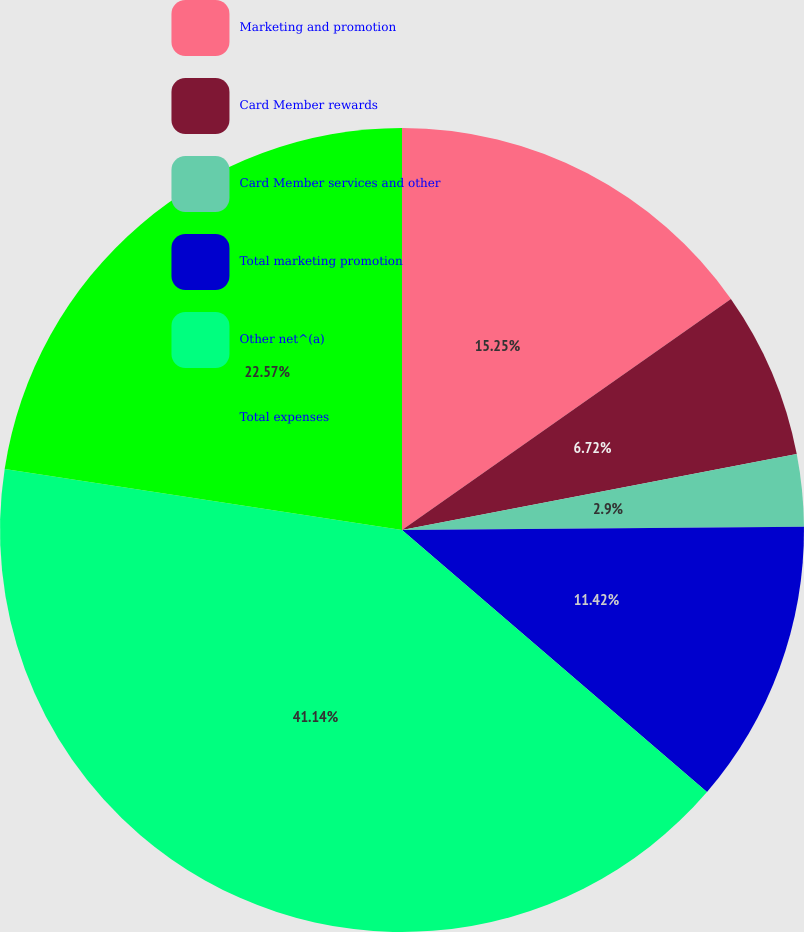Convert chart to OTSL. <chart><loc_0><loc_0><loc_500><loc_500><pie_chart><fcel>Marketing and promotion<fcel>Card Member rewards<fcel>Card Member services and other<fcel>Total marketing promotion<fcel>Other net^(a)<fcel>Total expenses<nl><fcel>15.25%<fcel>6.72%<fcel>2.9%<fcel>11.42%<fcel>41.13%<fcel>22.57%<nl></chart> 